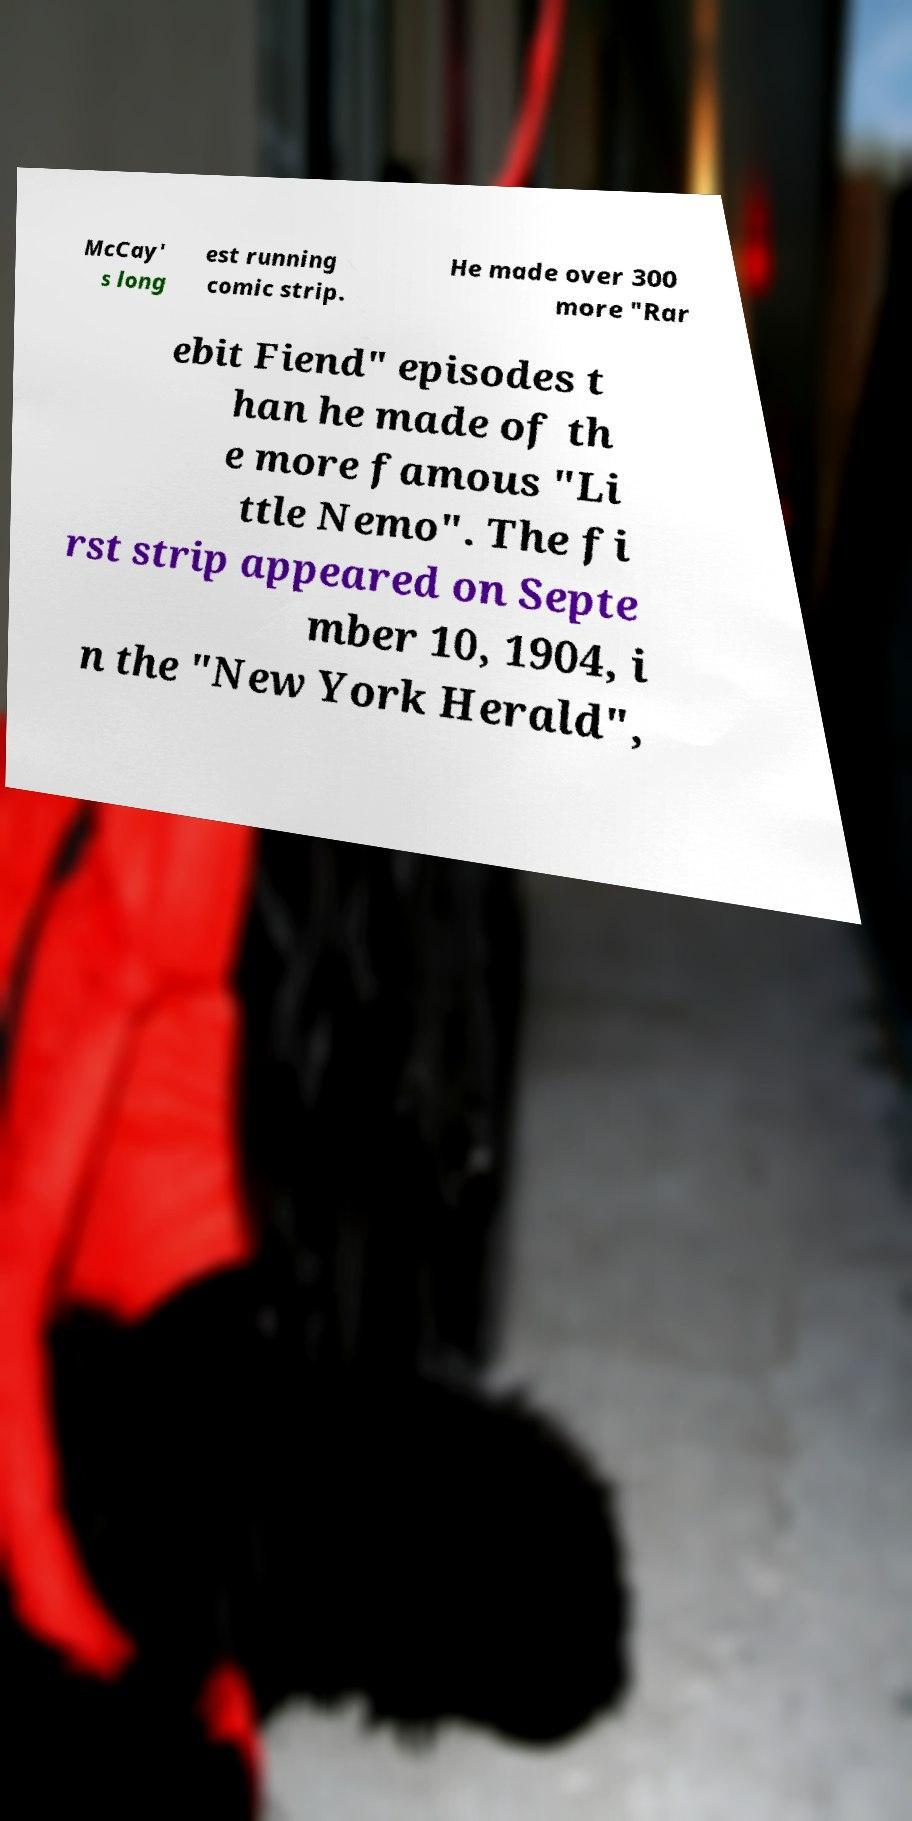Could you assist in decoding the text presented in this image and type it out clearly? McCay' s long est running comic strip. He made over 300 more "Rar ebit Fiend" episodes t han he made of th e more famous "Li ttle Nemo". The fi rst strip appeared on Septe mber 10, 1904, i n the "New York Herald", 